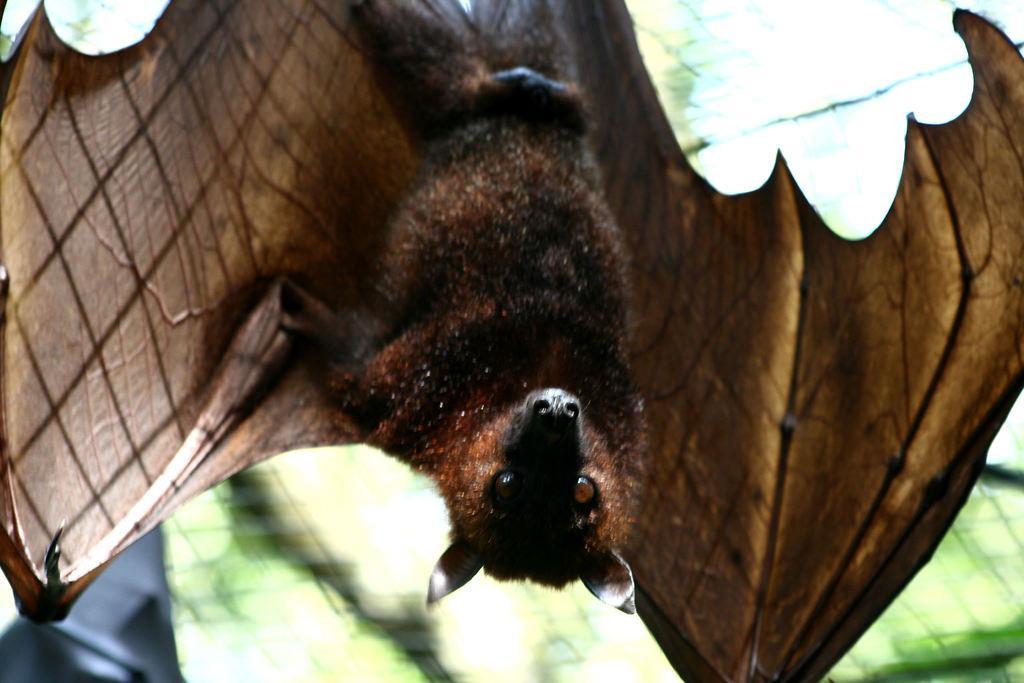How would you summarize this image in a sentence or two? In this image, we can see a bat on the blur background. 